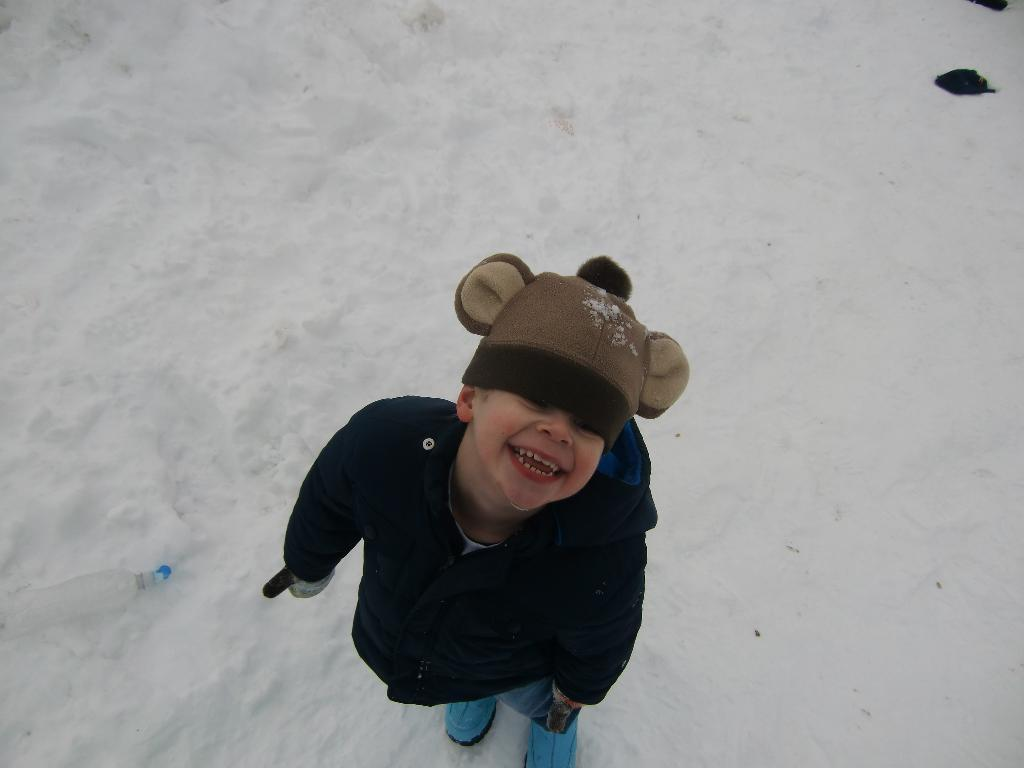What is the main subject of the image? The main subject of the image is a kid. What is the kid standing on? The kid is standing on the snow. Are there any other objects or elements in the image besides the kid? Yes, there are some objects in the image. What type of border is visible in the image? There is no border visible in the image; it features a kid standing on the snow with some unspecified objects. 